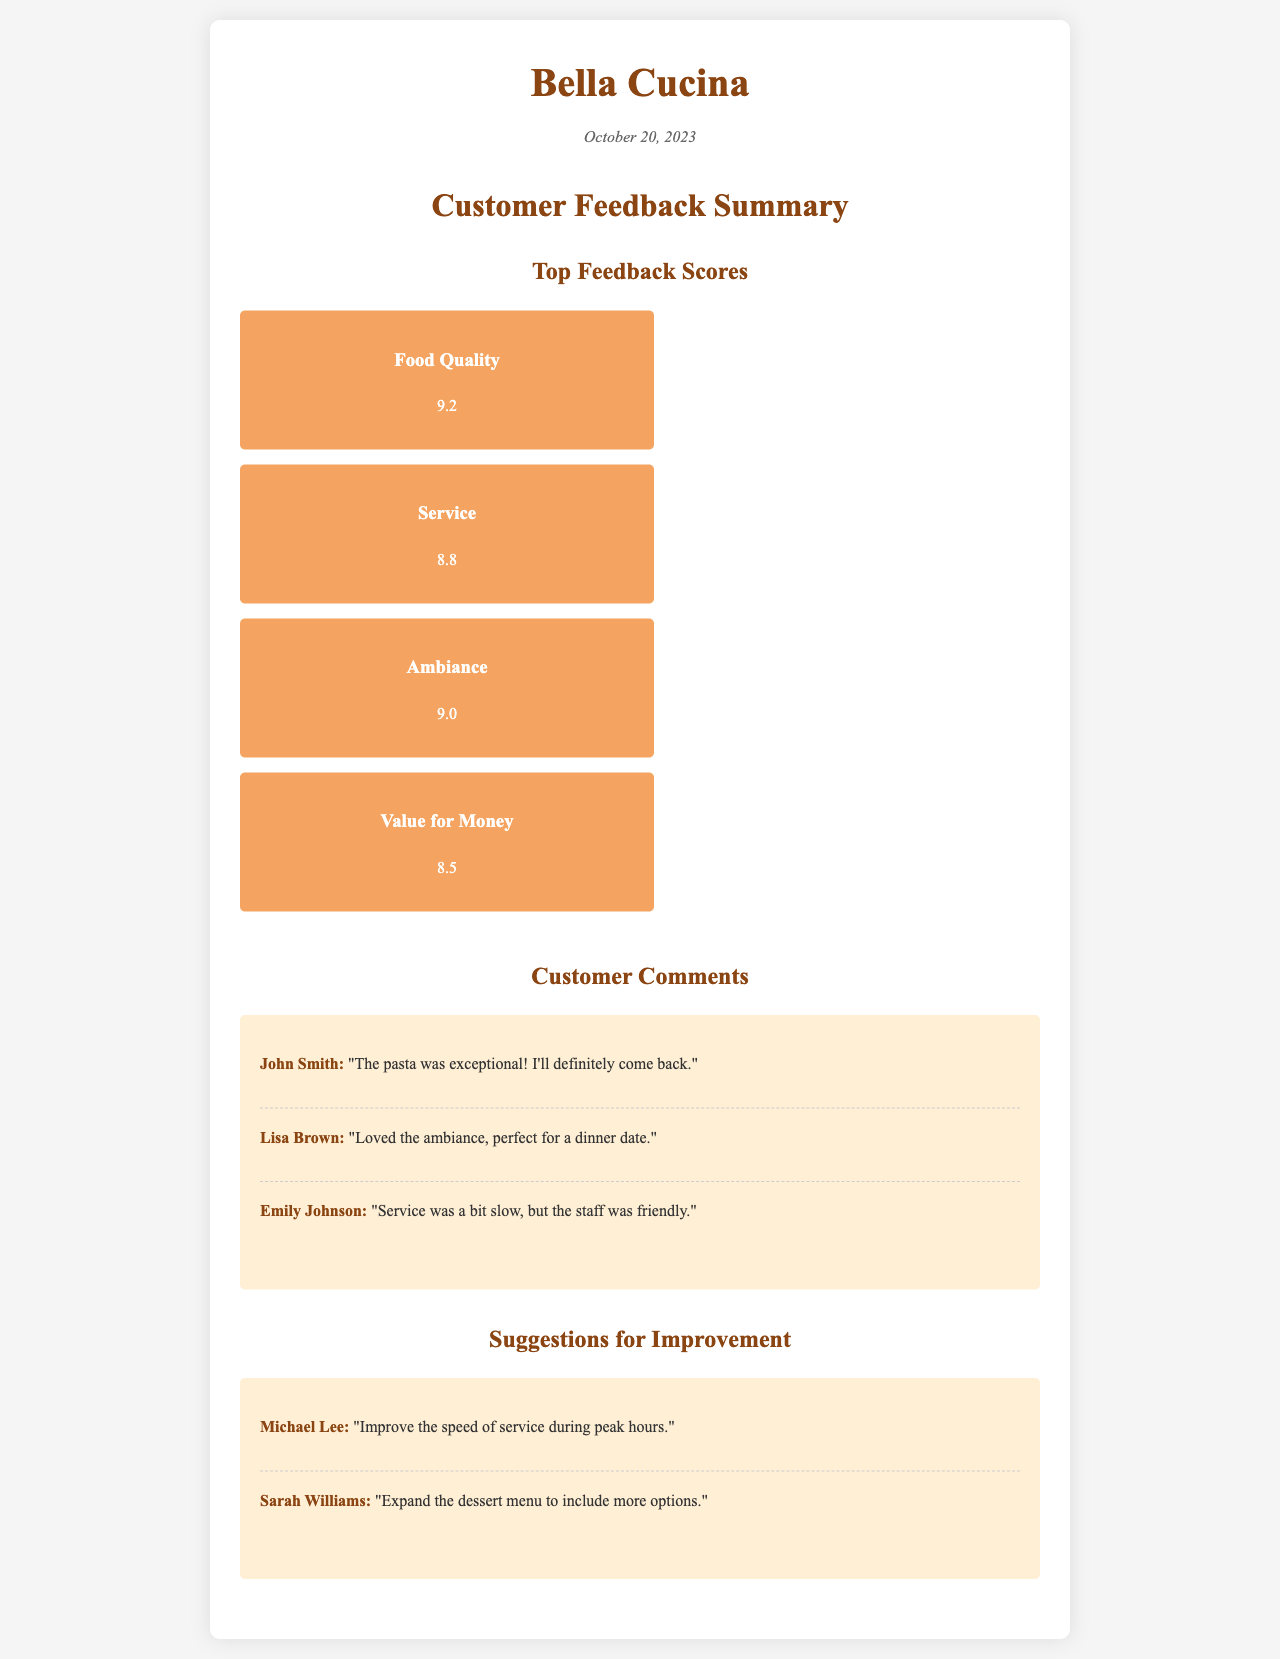What is the highest feedback score? The highest feedback score is located under the "Top Feedback Scores" section and refers to "Food Quality," which received a score of 9.2.
Answer: 9.2 What date was the feedback summary generated? The date is stated at the top under the "date" section, which shows October 20, 2023.
Answer: October 20, 2023 Who commented on the food quality? The name associated with the positive comment on food quality is "John Smith," who praised the pasta.
Answer: John Smith What score was given for Service? The score for "Service" is explicitly mentioned in the "Top Feedback Scores" section.
Answer: 8.8 What suggestion was made concerning service? The suggestion regarding service improvement is found in the "Suggestions for Improvement" section and was made by Michael Lee.
Answer: Improve the speed of service during peak hours Which aspect received the lowest score? The aspect with the lowest score under "Top Feedback Scores" is "Value for Money," which is clearly indicated.
Answer: 8.5 How many customer comments are listed in the document? The document specifies three customer comments in the "Customer Comments" section.
Answer: Three Who suggested expanding the dessert menu? The suggestion to expand the dessert menu is attributed to Sarah Williams, as seen in the "Suggestions for Improvement" section.
Answer: Sarah Williams What is the score for Ambiance? The score for "Ambiance" is provided in the "Top Feedback Scores" section of the document.
Answer: 9.0 